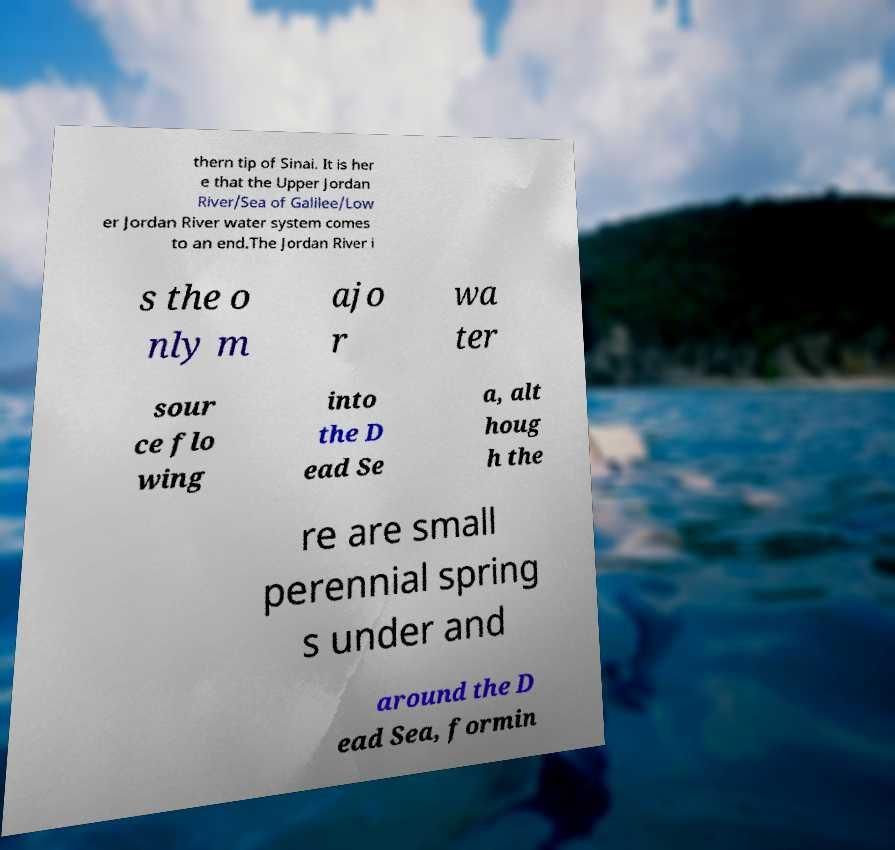Please identify and transcribe the text found in this image. thern tip of Sinai. It is her e that the Upper Jordan River/Sea of Galilee/Low er Jordan River water system comes to an end.The Jordan River i s the o nly m ajo r wa ter sour ce flo wing into the D ead Se a, alt houg h the re are small perennial spring s under and around the D ead Sea, formin 